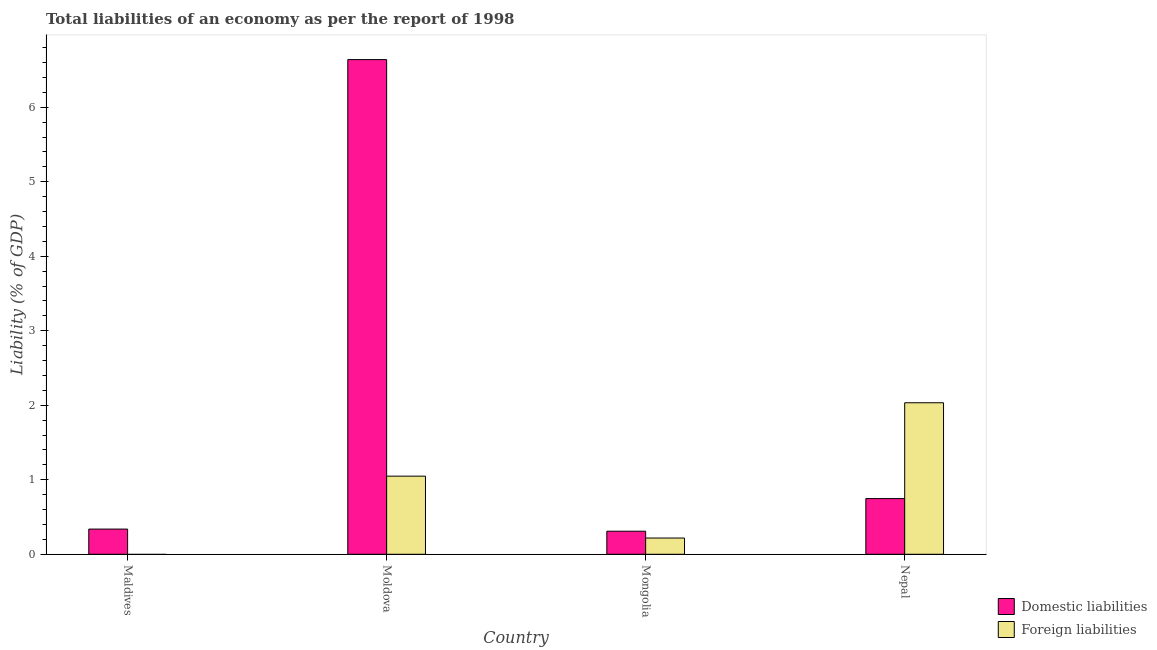How many different coloured bars are there?
Give a very brief answer. 2. Are the number of bars per tick equal to the number of legend labels?
Keep it short and to the point. No. Are the number of bars on each tick of the X-axis equal?
Offer a terse response. No. How many bars are there on the 4th tick from the left?
Offer a very short reply. 2. How many bars are there on the 4th tick from the right?
Give a very brief answer. 1. What is the label of the 3rd group of bars from the left?
Make the answer very short. Mongolia. What is the incurrence of foreign liabilities in Nepal?
Give a very brief answer. 2.03. Across all countries, what is the maximum incurrence of domestic liabilities?
Offer a very short reply. 6.64. Across all countries, what is the minimum incurrence of foreign liabilities?
Provide a short and direct response. 0. In which country was the incurrence of domestic liabilities maximum?
Give a very brief answer. Moldova. What is the total incurrence of domestic liabilities in the graph?
Provide a short and direct response. 8.04. What is the difference between the incurrence of foreign liabilities in Moldova and that in Mongolia?
Provide a short and direct response. 0.83. What is the difference between the incurrence of foreign liabilities in Maldives and the incurrence of domestic liabilities in Nepal?
Offer a terse response. -0.75. What is the average incurrence of foreign liabilities per country?
Offer a very short reply. 0.83. What is the difference between the incurrence of domestic liabilities and incurrence of foreign liabilities in Mongolia?
Offer a terse response. 0.09. What is the ratio of the incurrence of domestic liabilities in Maldives to that in Nepal?
Your response must be concise. 0.45. Is the incurrence of foreign liabilities in Mongolia less than that in Nepal?
Provide a short and direct response. Yes. Is the difference between the incurrence of foreign liabilities in Mongolia and Nepal greater than the difference between the incurrence of domestic liabilities in Mongolia and Nepal?
Give a very brief answer. No. What is the difference between the highest and the second highest incurrence of domestic liabilities?
Ensure brevity in your answer.  5.89. What is the difference between the highest and the lowest incurrence of foreign liabilities?
Offer a very short reply. 2.03. In how many countries, is the incurrence of foreign liabilities greater than the average incurrence of foreign liabilities taken over all countries?
Keep it short and to the point. 2. Is the sum of the incurrence of domestic liabilities in Moldova and Nepal greater than the maximum incurrence of foreign liabilities across all countries?
Your response must be concise. Yes. How many countries are there in the graph?
Your answer should be very brief. 4. Are the values on the major ticks of Y-axis written in scientific E-notation?
Provide a short and direct response. No. Does the graph contain any zero values?
Your response must be concise. Yes. Where does the legend appear in the graph?
Make the answer very short. Bottom right. How many legend labels are there?
Your answer should be very brief. 2. How are the legend labels stacked?
Your answer should be compact. Vertical. What is the title of the graph?
Your response must be concise. Total liabilities of an economy as per the report of 1998. What is the label or title of the Y-axis?
Your answer should be very brief. Liability (% of GDP). What is the Liability (% of GDP) of Domestic liabilities in Maldives?
Provide a succinct answer. 0.34. What is the Liability (% of GDP) in Domestic liabilities in Moldova?
Give a very brief answer. 6.64. What is the Liability (% of GDP) of Foreign liabilities in Moldova?
Your answer should be compact. 1.05. What is the Liability (% of GDP) in Domestic liabilities in Mongolia?
Offer a very short reply. 0.31. What is the Liability (% of GDP) in Foreign liabilities in Mongolia?
Your answer should be very brief. 0.22. What is the Liability (% of GDP) in Domestic liabilities in Nepal?
Provide a succinct answer. 0.75. What is the Liability (% of GDP) in Foreign liabilities in Nepal?
Offer a terse response. 2.03. Across all countries, what is the maximum Liability (% of GDP) in Domestic liabilities?
Keep it short and to the point. 6.64. Across all countries, what is the maximum Liability (% of GDP) in Foreign liabilities?
Your answer should be very brief. 2.03. Across all countries, what is the minimum Liability (% of GDP) of Domestic liabilities?
Offer a very short reply. 0.31. Across all countries, what is the minimum Liability (% of GDP) in Foreign liabilities?
Your answer should be very brief. 0. What is the total Liability (% of GDP) of Domestic liabilities in the graph?
Keep it short and to the point. 8.04. What is the total Liability (% of GDP) of Foreign liabilities in the graph?
Offer a terse response. 3.3. What is the difference between the Liability (% of GDP) in Domestic liabilities in Maldives and that in Moldova?
Keep it short and to the point. -6.3. What is the difference between the Liability (% of GDP) of Domestic liabilities in Maldives and that in Mongolia?
Your answer should be compact. 0.03. What is the difference between the Liability (% of GDP) of Domestic liabilities in Maldives and that in Nepal?
Your answer should be very brief. -0.41. What is the difference between the Liability (% of GDP) in Domestic liabilities in Moldova and that in Mongolia?
Make the answer very short. 6.33. What is the difference between the Liability (% of GDP) of Foreign liabilities in Moldova and that in Mongolia?
Your answer should be compact. 0.83. What is the difference between the Liability (% of GDP) of Domestic liabilities in Moldova and that in Nepal?
Offer a terse response. 5.89. What is the difference between the Liability (% of GDP) of Foreign liabilities in Moldova and that in Nepal?
Offer a very short reply. -0.99. What is the difference between the Liability (% of GDP) of Domestic liabilities in Mongolia and that in Nepal?
Give a very brief answer. -0.44. What is the difference between the Liability (% of GDP) in Foreign liabilities in Mongolia and that in Nepal?
Your answer should be very brief. -1.82. What is the difference between the Liability (% of GDP) in Domestic liabilities in Maldives and the Liability (% of GDP) in Foreign liabilities in Moldova?
Keep it short and to the point. -0.71. What is the difference between the Liability (% of GDP) of Domestic liabilities in Maldives and the Liability (% of GDP) of Foreign liabilities in Mongolia?
Your answer should be compact. 0.12. What is the difference between the Liability (% of GDP) of Domestic liabilities in Maldives and the Liability (% of GDP) of Foreign liabilities in Nepal?
Keep it short and to the point. -1.7. What is the difference between the Liability (% of GDP) of Domestic liabilities in Moldova and the Liability (% of GDP) of Foreign liabilities in Mongolia?
Make the answer very short. 6.42. What is the difference between the Liability (% of GDP) of Domestic liabilities in Moldova and the Liability (% of GDP) of Foreign liabilities in Nepal?
Offer a very short reply. 4.61. What is the difference between the Liability (% of GDP) of Domestic liabilities in Mongolia and the Liability (% of GDP) of Foreign liabilities in Nepal?
Give a very brief answer. -1.72. What is the average Liability (% of GDP) of Domestic liabilities per country?
Offer a very short reply. 2.01. What is the average Liability (% of GDP) in Foreign liabilities per country?
Offer a very short reply. 0.83. What is the difference between the Liability (% of GDP) in Domestic liabilities and Liability (% of GDP) in Foreign liabilities in Moldova?
Ensure brevity in your answer.  5.59. What is the difference between the Liability (% of GDP) of Domestic liabilities and Liability (% of GDP) of Foreign liabilities in Mongolia?
Your answer should be very brief. 0.09. What is the difference between the Liability (% of GDP) in Domestic liabilities and Liability (% of GDP) in Foreign liabilities in Nepal?
Give a very brief answer. -1.29. What is the ratio of the Liability (% of GDP) of Domestic liabilities in Maldives to that in Moldova?
Provide a short and direct response. 0.05. What is the ratio of the Liability (% of GDP) of Domestic liabilities in Maldives to that in Mongolia?
Provide a succinct answer. 1.09. What is the ratio of the Liability (% of GDP) of Domestic liabilities in Maldives to that in Nepal?
Your response must be concise. 0.45. What is the ratio of the Liability (% of GDP) in Domestic liabilities in Moldova to that in Mongolia?
Make the answer very short. 21.45. What is the ratio of the Liability (% of GDP) in Foreign liabilities in Moldova to that in Mongolia?
Offer a terse response. 4.81. What is the ratio of the Liability (% of GDP) in Domestic liabilities in Moldova to that in Nepal?
Your answer should be very brief. 8.88. What is the ratio of the Liability (% of GDP) of Foreign liabilities in Moldova to that in Nepal?
Your answer should be very brief. 0.52. What is the ratio of the Liability (% of GDP) of Domestic liabilities in Mongolia to that in Nepal?
Your response must be concise. 0.41. What is the ratio of the Liability (% of GDP) of Foreign liabilities in Mongolia to that in Nepal?
Your answer should be compact. 0.11. What is the difference between the highest and the second highest Liability (% of GDP) in Domestic liabilities?
Provide a short and direct response. 5.89. What is the difference between the highest and the second highest Liability (% of GDP) of Foreign liabilities?
Offer a very short reply. 0.99. What is the difference between the highest and the lowest Liability (% of GDP) of Domestic liabilities?
Provide a succinct answer. 6.33. What is the difference between the highest and the lowest Liability (% of GDP) of Foreign liabilities?
Ensure brevity in your answer.  2.03. 